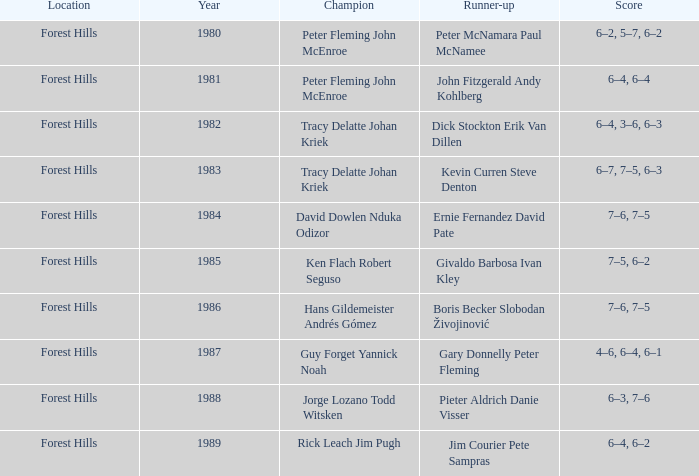Which individuals or teams were victorious in 1988? Jorge Lozano Todd Witsken. 